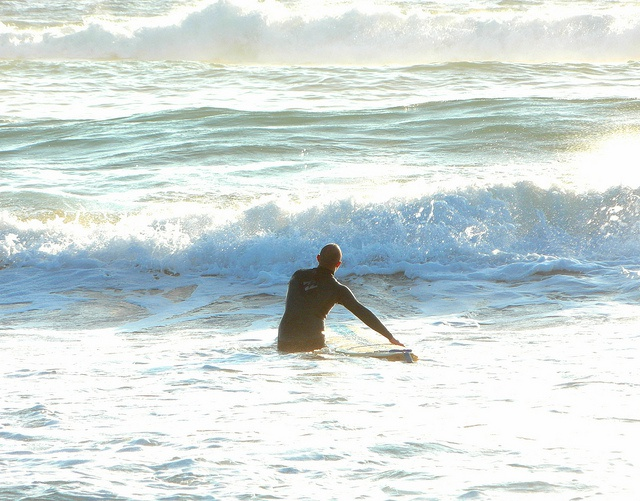Describe the objects in this image and their specific colors. I can see people in darkgray, gray, and black tones, surfboard in darkgray, beige, and gray tones, and surfboard in darkgray, white, and tan tones in this image. 